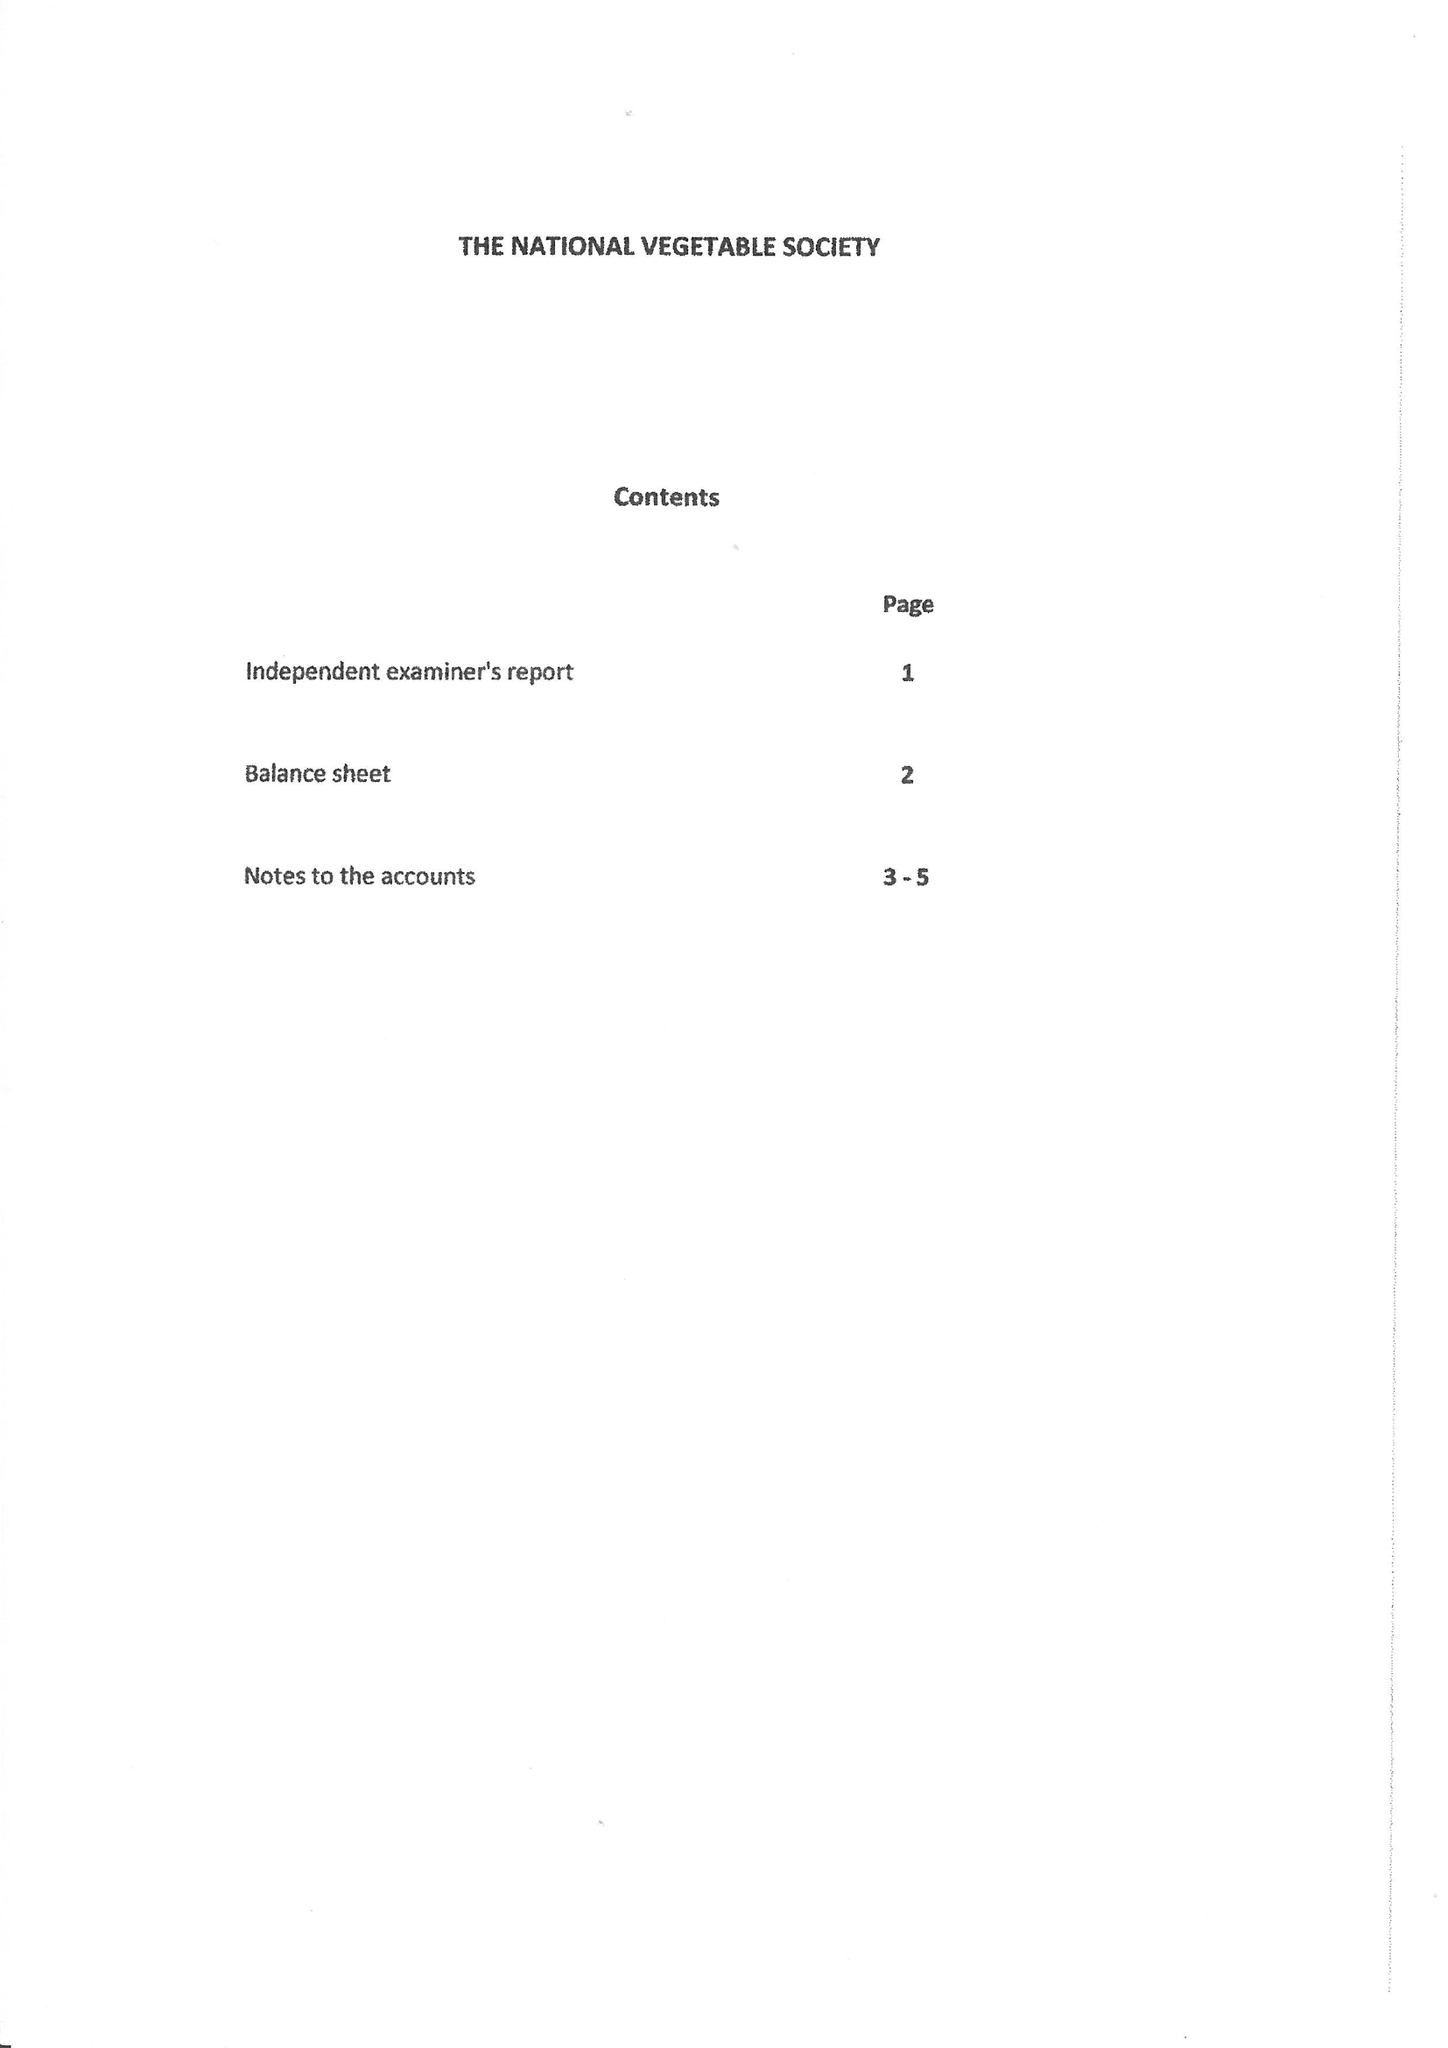What is the value for the income_annually_in_british_pounds?
Answer the question using a single word or phrase. 119789.00 